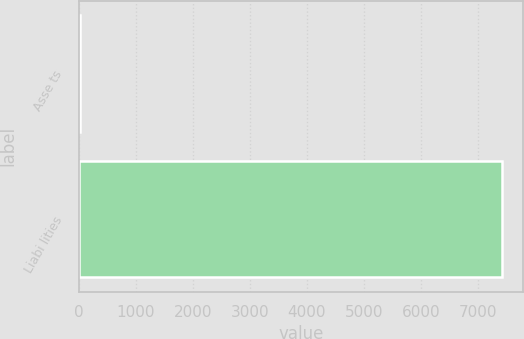Convert chart to OTSL. <chart><loc_0><loc_0><loc_500><loc_500><bar_chart><fcel>Asse ts<fcel>Liabi lities<nl><fcel>33<fcel>7423<nl></chart> 